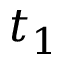Convert formula to latex. <formula><loc_0><loc_0><loc_500><loc_500>t _ { 1 }</formula> 